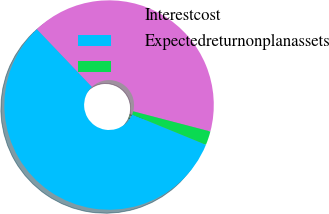Convert chart. <chart><loc_0><loc_0><loc_500><loc_500><pie_chart><fcel>Interestcost<fcel>Expectedreturnonplanassets<fcel>Unnamed: 2<nl><fcel>41.19%<fcel>56.69%<fcel>2.12%<nl></chart> 